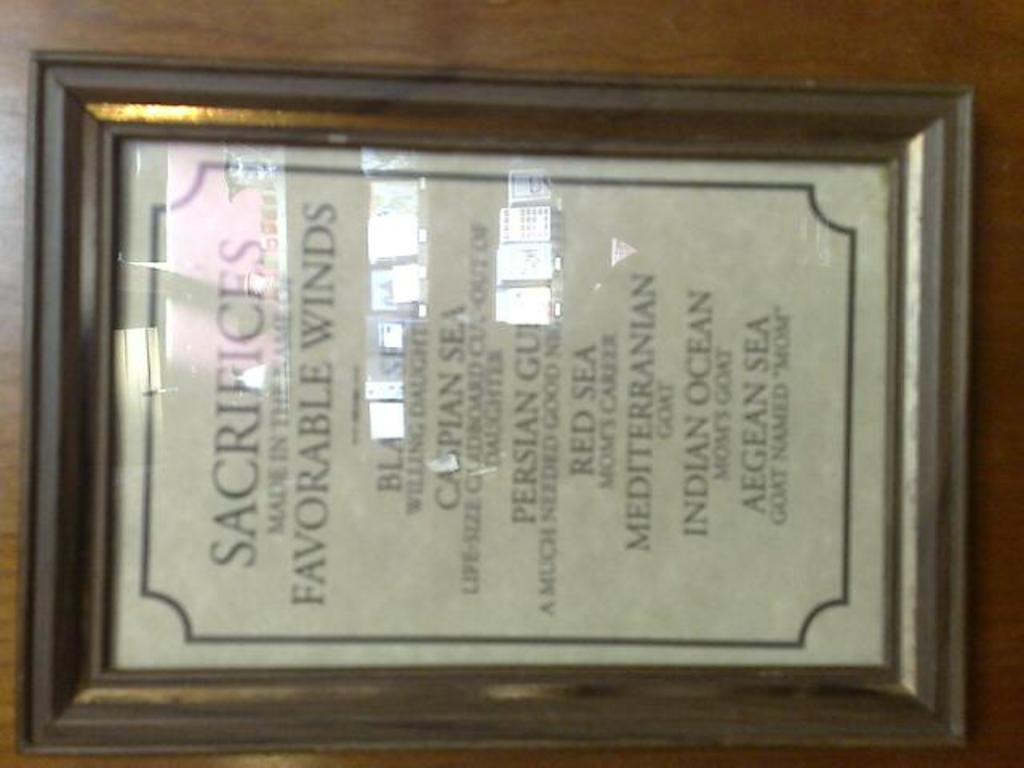<image>
Relay a brief, clear account of the picture shown. A framed play bill for the play Sacrifices made in the name of Favorable winds 